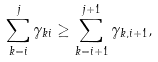Convert formula to latex. <formula><loc_0><loc_0><loc_500><loc_500>\sum _ { k = i } ^ { j } \gamma _ { k i } \geq \sum _ { k = i + 1 } ^ { j + 1 } \gamma _ { k , i + 1 } ,</formula> 